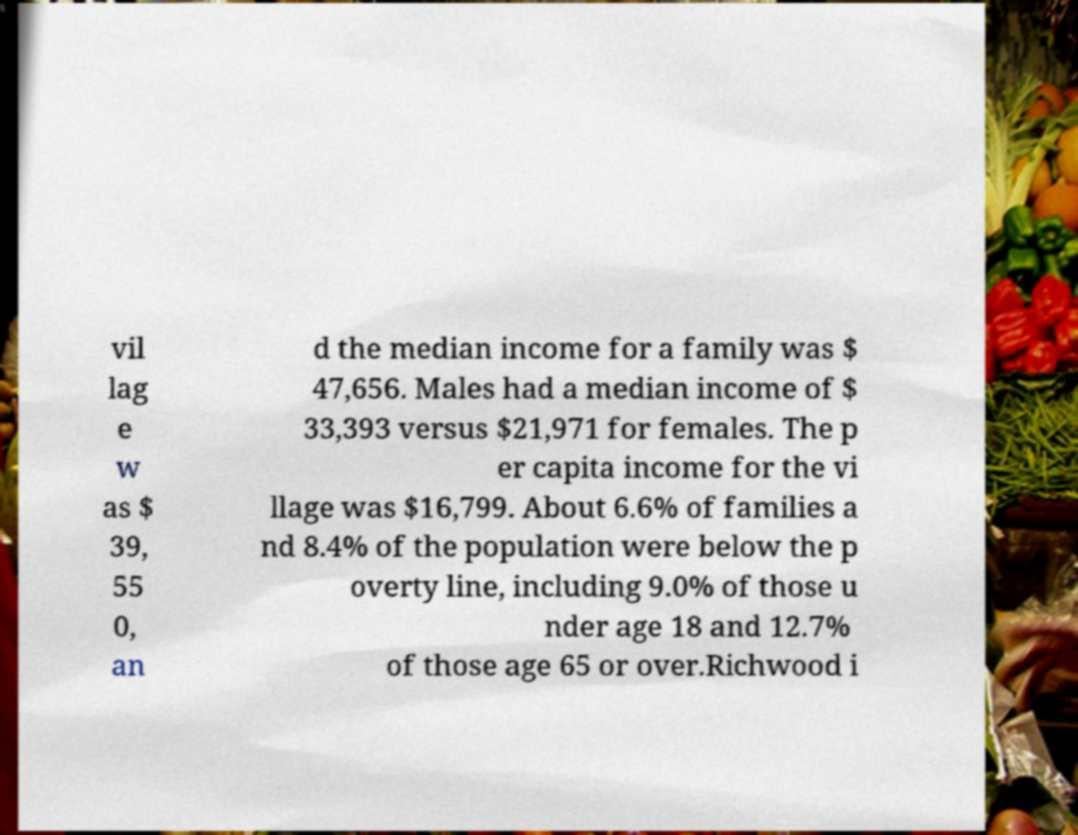Can you read and provide the text displayed in the image?This photo seems to have some interesting text. Can you extract and type it out for me? vil lag e w as $ 39, 55 0, an d the median income for a family was $ 47,656. Males had a median income of $ 33,393 versus $21,971 for females. The p er capita income for the vi llage was $16,799. About 6.6% of families a nd 8.4% of the population were below the p overty line, including 9.0% of those u nder age 18 and 12.7% of those age 65 or over.Richwood i 